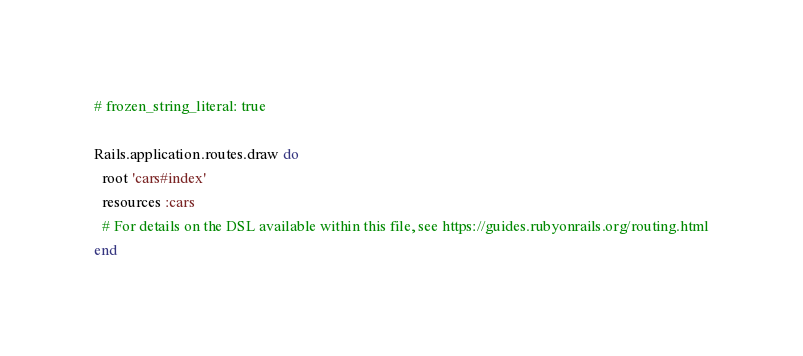<code> <loc_0><loc_0><loc_500><loc_500><_Ruby_># frozen_string_literal: true

Rails.application.routes.draw do
  root 'cars#index'
  resources :cars
  # For details on the DSL available within this file, see https://guides.rubyonrails.org/routing.html
end
</code> 